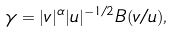<formula> <loc_0><loc_0><loc_500><loc_500>\gamma = | v | ^ { \alpha } | u | ^ { - 1 / 2 } B ( v / u ) ,</formula> 